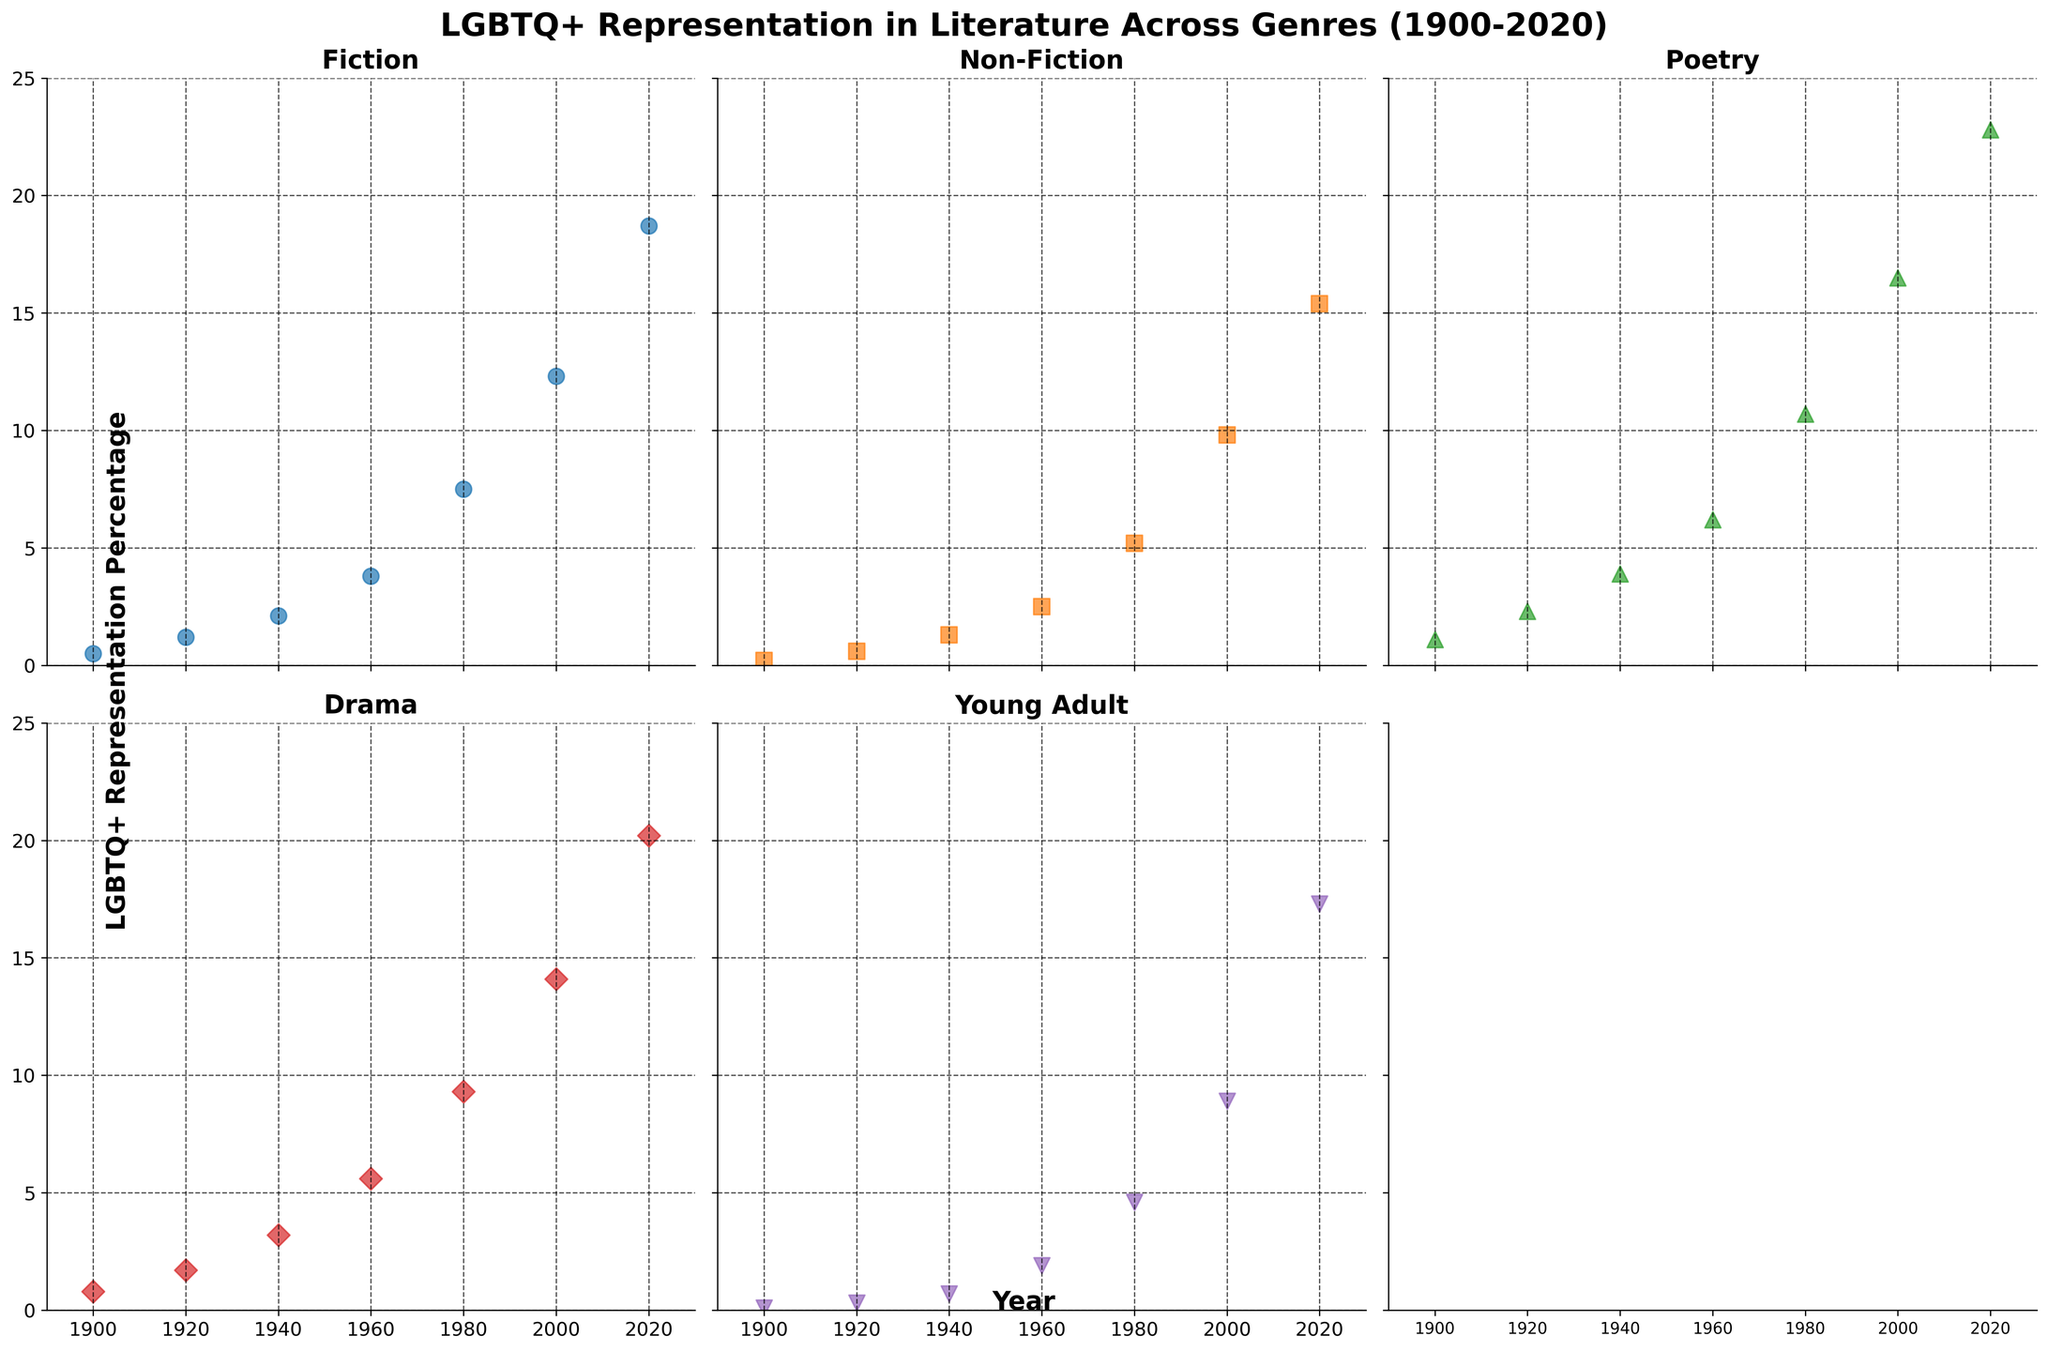What genre shows the highest LGBTQ+ representation in the year 2020? From the figure, in 2020, Poetry shows the highest LGBTQ+ representation as it is at the highest point numerically.
Answer: Poetry Which genre experienced the most significant increase in LGBTQ+ representation from 1900 to 2020? Comparing the starting and ending points for all genres from 1900 to 2020, the most considerable rise is seen in Poetry going from 1.1% to 22.8%, a 21.7% increase.
Answer: Poetry How many genres have an LGBTQ+ representation percentage below 10% in the year 2000? For the year 2000, four genres fall below the 10%; Fiction, Non-Fiction, Drama, and Young Adult, while Poetry exceeds 10%.
Answer: 4 Which genre witnessed the smallest change in LGBTQ+ representation between 1980 to 2000? By calculating the differences between 1980 and 2000, Fiction increased by 4.8%, Non-Fiction by 4.6%, Poetry by 5.8%, Drama by 4.8%, and Young Adult by 4.3%. The smallest change is in Young Adult.
Answer: Young Adult Was LGBTQ+ representation higher in Fiction or Drama in 1960? For the year 1960, Fiction shows approximately 3.8%, while Drama represents around 5.6%, indicating higher LGBTQ+ representation in Drama.
Answer: Drama What is the average LGBTQ+ representation percentage in 2020 across all genres? Summing up the 2020 values for all genres (18.7, 15.4, 22.8, 20.2, 17.3) and dividing by 5 results in an average of 18.88%.
Answer: 18.88% Which genre displayed the steepest increase in LGBTQ+ representation percentage from 1940 to 1960? By examining the slopes between 1940 and 1960, Fiction increased by 1.7%, Non-Fiction by 1.2%, Poetry by 2.3%, Drama by 2.4%, and Young Adult by 1.2%. Drama shows the steepest increase.
Answer: Drama Do any genres show non-linear trends in their LGBTQ+ representation trajectories? Analyzing the patterns visually, Fiction, Non-Fiction, and Young Adult exhibit relatively consistent (linear) trends, while Poetry and Drama show noticeable non-linear growth, particularly accelerating in the later years.
Answer: Poetry, Drama Between which consecutive time periods does Fiction show the largest increase in LGBTQ+ representation? Observing the largest slope change in Fiction, the period between 1980 and 2000 has the highest increase, going from 7.5% to 12.3%, a 4.8% rise.
Answer: 1980 to 2000 